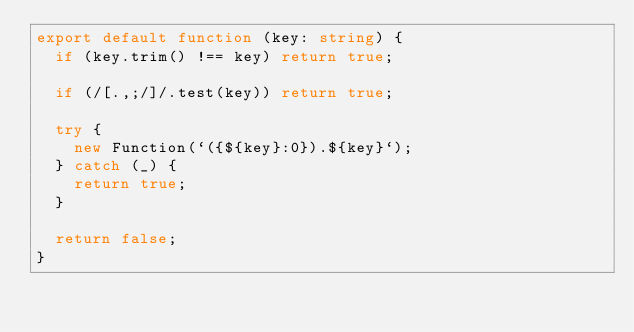Convert code to text. <code><loc_0><loc_0><loc_500><loc_500><_TypeScript_>export default function (key: string) {
  if (key.trim() !== key) return true;

  if (/[.,;/]/.test(key)) return true;

  try {
    new Function(`({${key}:0}).${key}`);
  } catch (_) {
    return true;
  }

  return false;
}
</code> 